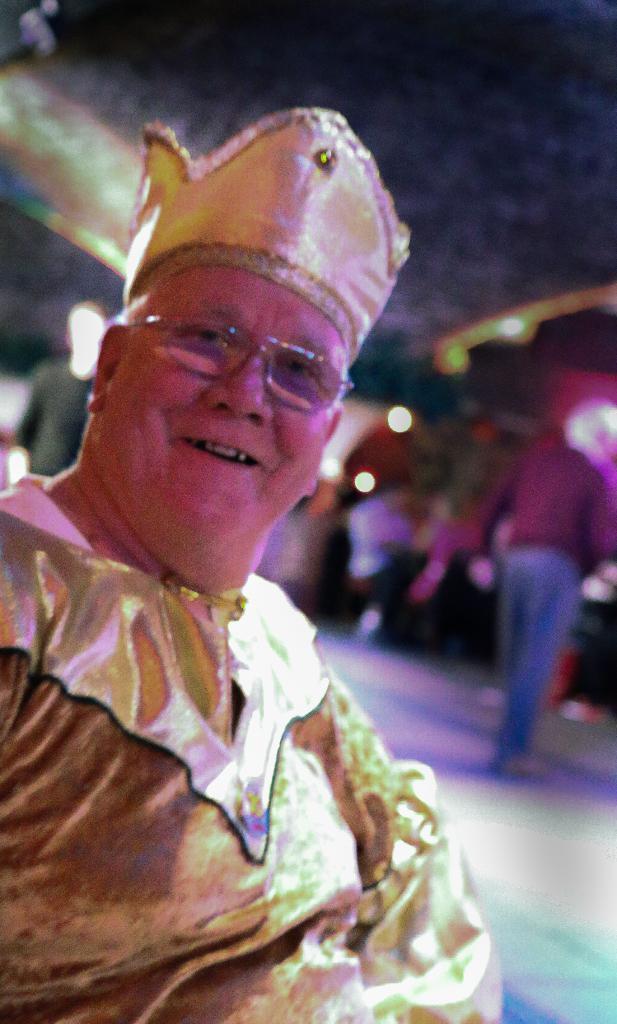In one or two sentences, can you explain what this image depicts? In this picture we can observe a person. This person is wearing gold color dress and spectacles. We can observe a cap on this person's head. This person is smiling. In the background there are some people sitting and standing. 